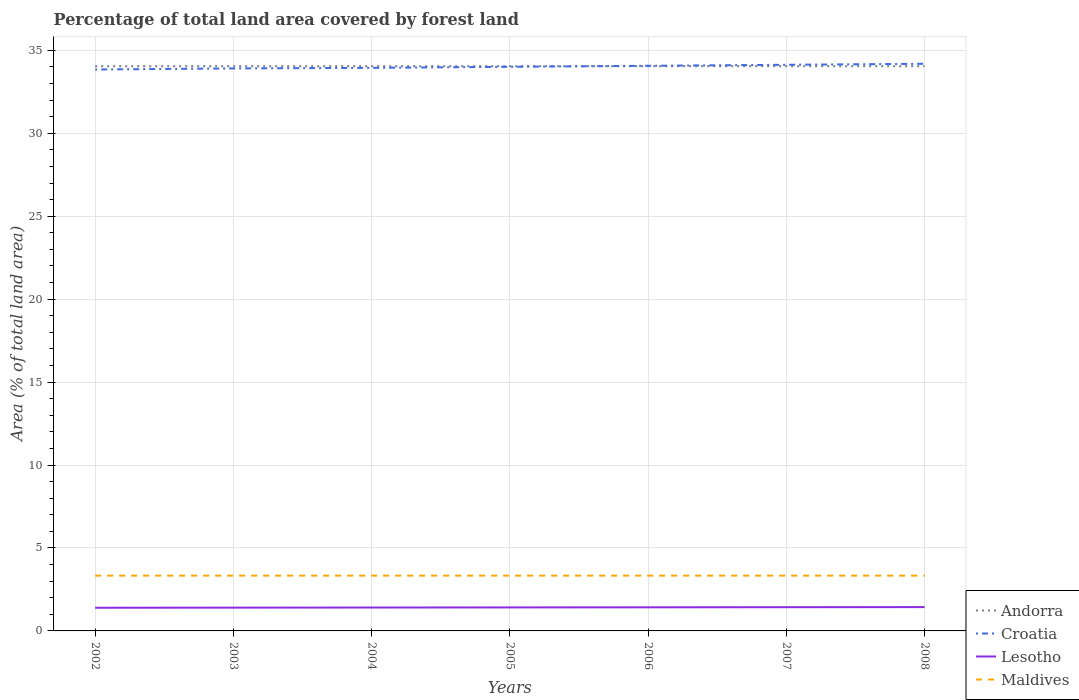How many different coloured lines are there?
Give a very brief answer. 4. Does the line corresponding to Croatia intersect with the line corresponding to Andorra?
Make the answer very short. Yes. Across all years, what is the maximum percentage of forest land in Croatia?
Keep it short and to the point. 33.84. What is the total percentage of forest land in Croatia in the graph?
Give a very brief answer. -0.16. What is the difference between the highest and the lowest percentage of forest land in Maldives?
Keep it short and to the point. 7. Is the percentage of forest land in Maldives strictly greater than the percentage of forest land in Croatia over the years?
Ensure brevity in your answer.  Yes. Are the values on the major ticks of Y-axis written in scientific E-notation?
Offer a very short reply. No. Where does the legend appear in the graph?
Provide a succinct answer. Bottom right. How many legend labels are there?
Provide a short and direct response. 4. What is the title of the graph?
Your response must be concise. Percentage of total land area covered by forest land. What is the label or title of the X-axis?
Give a very brief answer. Years. What is the label or title of the Y-axis?
Provide a short and direct response. Area (% of total land area). What is the Area (% of total land area) of Andorra in 2002?
Provide a short and direct response. 34.04. What is the Area (% of total land area) of Croatia in 2002?
Keep it short and to the point. 33.84. What is the Area (% of total land area) in Lesotho in 2002?
Your answer should be very brief. 1.4. What is the Area (% of total land area) of Maldives in 2002?
Give a very brief answer. 3.33. What is the Area (% of total land area) of Andorra in 2003?
Your answer should be very brief. 34.04. What is the Area (% of total land area) of Croatia in 2003?
Give a very brief answer. 33.91. What is the Area (% of total land area) of Lesotho in 2003?
Keep it short and to the point. 1.4. What is the Area (% of total land area) in Maldives in 2003?
Offer a terse response. 3.33. What is the Area (% of total land area) in Andorra in 2004?
Offer a very short reply. 34.04. What is the Area (% of total land area) in Croatia in 2004?
Your answer should be very brief. 33.94. What is the Area (% of total land area) of Lesotho in 2004?
Ensure brevity in your answer.  1.41. What is the Area (% of total land area) in Maldives in 2004?
Your answer should be very brief. 3.33. What is the Area (% of total land area) of Andorra in 2005?
Provide a short and direct response. 34.04. What is the Area (% of total land area) of Croatia in 2005?
Offer a terse response. 34.01. What is the Area (% of total land area) of Lesotho in 2005?
Keep it short and to the point. 1.42. What is the Area (% of total land area) in Maldives in 2005?
Give a very brief answer. 3.33. What is the Area (% of total land area) of Andorra in 2006?
Make the answer very short. 34.04. What is the Area (% of total land area) in Croatia in 2006?
Offer a very short reply. 34.07. What is the Area (% of total land area) in Lesotho in 2006?
Your answer should be compact. 1.42. What is the Area (% of total land area) in Maldives in 2006?
Provide a succinct answer. 3.33. What is the Area (% of total land area) in Andorra in 2007?
Make the answer very short. 34.04. What is the Area (% of total land area) of Croatia in 2007?
Keep it short and to the point. 34.13. What is the Area (% of total land area) in Lesotho in 2007?
Offer a very short reply. 1.43. What is the Area (% of total land area) in Maldives in 2007?
Keep it short and to the point. 3.33. What is the Area (% of total land area) in Andorra in 2008?
Keep it short and to the point. 34.04. What is the Area (% of total land area) in Croatia in 2008?
Your answer should be compact. 34.19. What is the Area (% of total land area) in Lesotho in 2008?
Provide a short and direct response. 1.44. What is the Area (% of total land area) of Maldives in 2008?
Your answer should be very brief. 3.33. Across all years, what is the maximum Area (% of total land area) in Andorra?
Your answer should be compact. 34.04. Across all years, what is the maximum Area (% of total land area) of Croatia?
Your answer should be very brief. 34.19. Across all years, what is the maximum Area (% of total land area) in Lesotho?
Provide a short and direct response. 1.44. Across all years, what is the maximum Area (% of total land area) of Maldives?
Provide a short and direct response. 3.33. Across all years, what is the minimum Area (% of total land area) of Andorra?
Give a very brief answer. 34.04. Across all years, what is the minimum Area (% of total land area) in Croatia?
Keep it short and to the point. 33.84. Across all years, what is the minimum Area (% of total land area) of Lesotho?
Give a very brief answer. 1.4. Across all years, what is the minimum Area (% of total land area) of Maldives?
Provide a succinct answer. 3.33. What is the total Area (% of total land area) of Andorra in the graph?
Your answer should be compact. 238.3. What is the total Area (% of total land area) in Croatia in the graph?
Give a very brief answer. 238.08. What is the total Area (% of total land area) in Lesotho in the graph?
Your answer should be compact. 9.91. What is the total Area (% of total land area) in Maldives in the graph?
Your response must be concise. 23.33. What is the difference between the Area (% of total land area) in Andorra in 2002 and that in 2003?
Offer a very short reply. 0. What is the difference between the Area (% of total land area) of Croatia in 2002 and that in 2003?
Provide a short and direct response. -0.06. What is the difference between the Area (% of total land area) of Lesotho in 2002 and that in 2003?
Your answer should be compact. -0.01. What is the difference between the Area (% of total land area) in Maldives in 2002 and that in 2003?
Keep it short and to the point. 0. What is the difference between the Area (% of total land area) of Croatia in 2002 and that in 2004?
Your answer should be very brief. -0.1. What is the difference between the Area (% of total land area) in Lesotho in 2002 and that in 2004?
Make the answer very short. -0.01. What is the difference between the Area (% of total land area) of Andorra in 2002 and that in 2005?
Offer a terse response. 0. What is the difference between the Area (% of total land area) of Croatia in 2002 and that in 2005?
Ensure brevity in your answer.  -0.16. What is the difference between the Area (% of total land area) of Lesotho in 2002 and that in 2005?
Offer a terse response. -0.02. What is the difference between the Area (% of total land area) of Andorra in 2002 and that in 2006?
Your response must be concise. 0. What is the difference between the Area (% of total land area) in Croatia in 2002 and that in 2006?
Provide a short and direct response. -0.22. What is the difference between the Area (% of total land area) of Lesotho in 2002 and that in 2006?
Your answer should be very brief. -0.03. What is the difference between the Area (% of total land area) in Andorra in 2002 and that in 2007?
Offer a terse response. 0. What is the difference between the Area (% of total land area) in Croatia in 2002 and that in 2007?
Give a very brief answer. -0.28. What is the difference between the Area (% of total land area) in Lesotho in 2002 and that in 2007?
Provide a succinct answer. -0.03. What is the difference between the Area (% of total land area) of Croatia in 2002 and that in 2008?
Provide a succinct answer. -0.34. What is the difference between the Area (% of total land area) of Lesotho in 2002 and that in 2008?
Your answer should be very brief. -0.04. What is the difference between the Area (% of total land area) in Andorra in 2003 and that in 2004?
Your answer should be compact. 0. What is the difference between the Area (% of total land area) of Croatia in 2003 and that in 2004?
Offer a terse response. -0.03. What is the difference between the Area (% of total land area) in Lesotho in 2003 and that in 2004?
Provide a short and direct response. -0.01. What is the difference between the Area (% of total land area) of Maldives in 2003 and that in 2004?
Your answer should be compact. 0. What is the difference between the Area (% of total land area) in Andorra in 2003 and that in 2005?
Your answer should be compact. 0. What is the difference between the Area (% of total land area) of Croatia in 2003 and that in 2005?
Provide a short and direct response. -0.1. What is the difference between the Area (% of total land area) of Lesotho in 2003 and that in 2005?
Give a very brief answer. -0.01. What is the difference between the Area (% of total land area) in Maldives in 2003 and that in 2005?
Offer a terse response. 0. What is the difference between the Area (% of total land area) of Croatia in 2003 and that in 2006?
Give a very brief answer. -0.16. What is the difference between the Area (% of total land area) in Lesotho in 2003 and that in 2006?
Make the answer very short. -0.02. What is the difference between the Area (% of total land area) in Croatia in 2003 and that in 2007?
Your answer should be very brief. -0.22. What is the difference between the Area (% of total land area) of Lesotho in 2003 and that in 2007?
Make the answer very short. -0.03. What is the difference between the Area (% of total land area) of Andorra in 2003 and that in 2008?
Offer a terse response. 0. What is the difference between the Area (% of total land area) in Croatia in 2003 and that in 2008?
Make the answer very short. -0.28. What is the difference between the Area (% of total land area) of Lesotho in 2003 and that in 2008?
Give a very brief answer. -0.03. What is the difference between the Area (% of total land area) of Maldives in 2003 and that in 2008?
Make the answer very short. 0. What is the difference between the Area (% of total land area) of Croatia in 2004 and that in 2005?
Your response must be concise. -0.06. What is the difference between the Area (% of total land area) in Lesotho in 2004 and that in 2005?
Ensure brevity in your answer.  -0.01. What is the difference between the Area (% of total land area) of Maldives in 2004 and that in 2005?
Offer a terse response. 0. What is the difference between the Area (% of total land area) of Croatia in 2004 and that in 2006?
Ensure brevity in your answer.  -0.13. What is the difference between the Area (% of total land area) in Lesotho in 2004 and that in 2006?
Give a very brief answer. -0.01. What is the difference between the Area (% of total land area) of Maldives in 2004 and that in 2006?
Your answer should be compact. 0. What is the difference between the Area (% of total land area) of Croatia in 2004 and that in 2007?
Make the answer very short. -0.19. What is the difference between the Area (% of total land area) in Lesotho in 2004 and that in 2007?
Your response must be concise. -0.02. What is the difference between the Area (% of total land area) of Andorra in 2004 and that in 2008?
Your response must be concise. 0. What is the difference between the Area (% of total land area) of Croatia in 2004 and that in 2008?
Keep it short and to the point. -0.25. What is the difference between the Area (% of total land area) of Lesotho in 2004 and that in 2008?
Your response must be concise. -0.03. What is the difference between the Area (% of total land area) in Croatia in 2005 and that in 2006?
Keep it short and to the point. -0.06. What is the difference between the Area (% of total land area) of Lesotho in 2005 and that in 2006?
Keep it short and to the point. -0.01. What is the difference between the Area (% of total land area) in Croatia in 2005 and that in 2007?
Offer a very short reply. -0.12. What is the difference between the Area (% of total land area) of Lesotho in 2005 and that in 2007?
Your answer should be compact. -0.01. What is the difference between the Area (% of total land area) in Croatia in 2005 and that in 2008?
Your answer should be very brief. -0.18. What is the difference between the Area (% of total land area) of Lesotho in 2005 and that in 2008?
Provide a short and direct response. -0.02. What is the difference between the Area (% of total land area) of Maldives in 2005 and that in 2008?
Provide a short and direct response. 0. What is the difference between the Area (% of total land area) in Andorra in 2006 and that in 2007?
Ensure brevity in your answer.  0. What is the difference between the Area (% of total land area) of Croatia in 2006 and that in 2007?
Keep it short and to the point. -0.06. What is the difference between the Area (% of total land area) of Lesotho in 2006 and that in 2007?
Give a very brief answer. -0.01. What is the difference between the Area (% of total land area) in Croatia in 2006 and that in 2008?
Give a very brief answer. -0.12. What is the difference between the Area (% of total land area) in Lesotho in 2006 and that in 2008?
Your response must be concise. -0.01. What is the difference between the Area (% of total land area) in Maldives in 2006 and that in 2008?
Ensure brevity in your answer.  0. What is the difference between the Area (% of total land area) in Andorra in 2007 and that in 2008?
Your response must be concise. 0. What is the difference between the Area (% of total land area) in Croatia in 2007 and that in 2008?
Give a very brief answer. -0.06. What is the difference between the Area (% of total land area) of Lesotho in 2007 and that in 2008?
Offer a terse response. -0.01. What is the difference between the Area (% of total land area) in Andorra in 2002 and the Area (% of total land area) in Croatia in 2003?
Offer a terse response. 0.13. What is the difference between the Area (% of total land area) of Andorra in 2002 and the Area (% of total land area) of Lesotho in 2003?
Offer a very short reply. 32.64. What is the difference between the Area (% of total land area) in Andorra in 2002 and the Area (% of total land area) in Maldives in 2003?
Provide a succinct answer. 30.71. What is the difference between the Area (% of total land area) of Croatia in 2002 and the Area (% of total land area) of Lesotho in 2003?
Offer a very short reply. 32.44. What is the difference between the Area (% of total land area) of Croatia in 2002 and the Area (% of total land area) of Maldives in 2003?
Ensure brevity in your answer.  30.51. What is the difference between the Area (% of total land area) of Lesotho in 2002 and the Area (% of total land area) of Maldives in 2003?
Offer a terse response. -1.94. What is the difference between the Area (% of total land area) in Andorra in 2002 and the Area (% of total land area) in Croatia in 2004?
Keep it short and to the point. 0.1. What is the difference between the Area (% of total land area) of Andorra in 2002 and the Area (% of total land area) of Lesotho in 2004?
Offer a very short reply. 32.63. What is the difference between the Area (% of total land area) in Andorra in 2002 and the Area (% of total land area) in Maldives in 2004?
Your answer should be compact. 30.71. What is the difference between the Area (% of total land area) of Croatia in 2002 and the Area (% of total land area) of Lesotho in 2004?
Make the answer very short. 32.43. What is the difference between the Area (% of total land area) in Croatia in 2002 and the Area (% of total land area) in Maldives in 2004?
Keep it short and to the point. 30.51. What is the difference between the Area (% of total land area) in Lesotho in 2002 and the Area (% of total land area) in Maldives in 2004?
Make the answer very short. -1.94. What is the difference between the Area (% of total land area) of Andorra in 2002 and the Area (% of total land area) of Croatia in 2005?
Your response must be concise. 0.04. What is the difference between the Area (% of total land area) in Andorra in 2002 and the Area (% of total land area) in Lesotho in 2005?
Offer a very short reply. 32.63. What is the difference between the Area (% of total land area) of Andorra in 2002 and the Area (% of total land area) of Maldives in 2005?
Provide a short and direct response. 30.71. What is the difference between the Area (% of total land area) of Croatia in 2002 and the Area (% of total land area) of Lesotho in 2005?
Your answer should be compact. 32.43. What is the difference between the Area (% of total land area) in Croatia in 2002 and the Area (% of total land area) in Maldives in 2005?
Your answer should be compact. 30.51. What is the difference between the Area (% of total land area) in Lesotho in 2002 and the Area (% of total land area) in Maldives in 2005?
Your answer should be very brief. -1.94. What is the difference between the Area (% of total land area) in Andorra in 2002 and the Area (% of total land area) in Croatia in 2006?
Provide a succinct answer. -0.02. What is the difference between the Area (% of total land area) of Andorra in 2002 and the Area (% of total land area) of Lesotho in 2006?
Ensure brevity in your answer.  32.62. What is the difference between the Area (% of total land area) of Andorra in 2002 and the Area (% of total land area) of Maldives in 2006?
Your answer should be compact. 30.71. What is the difference between the Area (% of total land area) in Croatia in 2002 and the Area (% of total land area) in Lesotho in 2006?
Provide a succinct answer. 32.42. What is the difference between the Area (% of total land area) in Croatia in 2002 and the Area (% of total land area) in Maldives in 2006?
Your answer should be compact. 30.51. What is the difference between the Area (% of total land area) of Lesotho in 2002 and the Area (% of total land area) of Maldives in 2006?
Make the answer very short. -1.94. What is the difference between the Area (% of total land area) in Andorra in 2002 and the Area (% of total land area) in Croatia in 2007?
Offer a terse response. -0.09. What is the difference between the Area (% of total land area) of Andorra in 2002 and the Area (% of total land area) of Lesotho in 2007?
Offer a terse response. 32.61. What is the difference between the Area (% of total land area) in Andorra in 2002 and the Area (% of total land area) in Maldives in 2007?
Your answer should be very brief. 30.71. What is the difference between the Area (% of total land area) in Croatia in 2002 and the Area (% of total land area) in Lesotho in 2007?
Provide a succinct answer. 32.41. What is the difference between the Area (% of total land area) of Croatia in 2002 and the Area (% of total land area) of Maldives in 2007?
Your answer should be compact. 30.51. What is the difference between the Area (% of total land area) in Lesotho in 2002 and the Area (% of total land area) in Maldives in 2007?
Provide a short and direct response. -1.94. What is the difference between the Area (% of total land area) in Andorra in 2002 and the Area (% of total land area) in Croatia in 2008?
Ensure brevity in your answer.  -0.15. What is the difference between the Area (% of total land area) in Andorra in 2002 and the Area (% of total land area) in Lesotho in 2008?
Provide a succinct answer. 32.61. What is the difference between the Area (% of total land area) of Andorra in 2002 and the Area (% of total land area) of Maldives in 2008?
Provide a succinct answer. 30.71. What is the difference between the Area (% of total land area) of Croatia in 2002 and the Area (% of total land area) of Lesotho in 2008?
Make the answer very short. 32.41. What is the difference between the Area (% of total land area) of Croatia in 2002 and the Area (% of total land area) of Maldives in 2008?
Your answer should be compact. 30.51. What is the difference between the Area (% of total land area) of Lesotho in 2002 and the Area (% of total land area) of Maldives in 2008?
Your response must be concise. -1.94. What is the difference between the Area (% of total land area) of Andorra in 2003 and the Area (% of total land area) of Croatia in 2004?
Your answer should be compact. 0.1. What is the difference between the Area (% of total land area) of Andorra in 2003 and the Area (% of total land area) of Lesotho in 2004?
Provide a succinct answer. 32.63. What is the difference between the Area (% of total land area) of Andorra in 2003 and the Area (% of total land area) of Maldives in 2004?
Keep it short and to the point. 30.71. What is the difference between the Area (% of total land area) in Croatia in 2003 and the Area (% of total land area) in Lesotho in 2004?
Ensure brevity in your answer.  32.5. What is the difference between the Area (% of total land area) in Croatia in 2003 and the Area (% of total land area) in Maldives in 2004?
Your answer should be compact. 30.57. What is the difference between the Area (% of total land area) of Lesotho in 2003 and the Area (% of total land area) of Maldives in 2004?
Offer a very short reply. -1.93. What is the difference between the Area (% of total land area) of Andorra in 2003 and the Area (% of total land area) of Croatia in 2005?
Offer a terse response. 0.04. What is the difference between the Area (% of total land area) of Andorra in 2003 and the Area (% of total land area) of Lesotho in 2005?
Provide a succinct answer. 32.63. What is the difference between the Area (% of total land area) of Andorra in 2003 and the Area (% of total land area) of Maldives in 2005?
Ensure brevity in your answer.  30.71. What is the difference between the Area (% of total land area) in Croatia in 2003 and the Area (% of total land area) in Lesotho in 2005?
Your answer should be very brief. 32.49. What is the difference between the Area (% of total land area) of Croatia in 2003 and the Area (% of total land area) of Maldives in 2005?
Keep it short and to the point. 30.57. What is the difference between the Area (% of total land area) in Lesotho in 2003 and the Area (% of total land area) in Maldives in 2005?
Provide a succinct answer. -1.93. What is the difference between the Area (% of total land area) in Andorra in 2003 and the Area (% of total land area) in Croatia in 2006?
Your answer should be compact. -0.02. What is the difference between the Area (% of total land area) in Andorra in 2003 and the Area (% of total land area) in Lesotho in 2006?
Make the answer very short. 32.62. What is the difference between the Area (% of total land area) of Andorra in 2003 and the Area (% of total land area) of Maldives in 2006?
Provide a short and direct response. 30.71. What is the difference between the Area (% of total land area) of Croatia in 2003 and the Area (% of total land area) of Lesotho in 2006?
Keep it short and to the point. 32.49. What is the difference between the Area (% of total land area) of Croatia in 2003 and the Area (% of total land area) of Maldives in 2006?
Make the answer very short. 30.57. What is the difference between the Area (% of total land area) in Lesotho in 2003 and the Area (% of total land area) in Maldives in 2006?
Offer a very short reply. -1.93. What is the difference between the Area (% of total land area) in Andorra in 2003 and the Area (% of total land area) in Croatia in 2007?
Make the answer very short. -0.09. What is the difference between the Area (% of total land area) of Andorra in 2003 and the Area (% of total land area) of Lesotho in 2007?
Keep it short and to the point. 32.61. What is the difference between the Area (% of total land area) of Andorra in 2003 and the Area (% of total land area) of Maldives in 2007?
Ensure brevity in your answer.  30.71. What is the difference between the Area (% of total land area) of Croatia in 2003 and the Area (% of total land area) of Lesotho in 2007?
Your answer should be compact. 32.48. What is the difference between the Area (% of total land area) of Croatia in 2003 and the Area (% of total land area) of Maldives in 2007?
Offer a very short reply. 30.57. What is the difference between the Area (% of total land area) in Lesotho in 2003 and the Area (% of total land area) in Maldives in 2007?
Provide a short and direct response. -1.93. What is the difference between the Area (% of total land area) of Andorra in 2003 and the Area (% of total land area) of Croatia in 2008?
Provide a short and direct response. -0.15. What is the difference between the Area (% of total land area) of Andorra in 2003 and the Area (% of total land area) of Lesotho in 2008?
Make the answer very short. 32.61. What is the difference between the Area (% of total land area) of Andorra in 2003 and the Area (% of total land area) of Maldives in 2008?
Your answer should be compact. 30.71. What is the difference between the Area (% of total land area) in Croatia in 2003 and the Area (% of total land area) in Lesotho in 2008?
Offer a very short reply. 32.47. What is the difference between the Area (% of total land area) in Croatia in 2003 and the Area (% of total land area) in Maldives in 2008?
Provide a succinct answer. 30.57. What is the difference between the Area (% of total land area) in Lesotho in 2003 and the Area (% of total land area) in Maldives in 2008?
Your response must be concise. -1.93. What is the difference between the Area (% of total land area) of Andorra in 2004 and the Area (% of total land area) of Croatia in 2005?
Offer a terse response. 0.04. What is the difference between the Area (% of total land area) in Andorra in 2004 and the Area (% of total land area) in Lesotho in 2005?
Make the answer very short. 32.63. What is the difference between the Area (% of total land area) in Andorra in 2004 and the Area (% of total land area) in Maldives in 2005?
Provide a short and direct response. 30.71. What is the difference between the Area (% of total land area) in Croatia in 2004 and the Area (% of total land area) in Lesotho in 2005?
Your response must be concise. 32.53. What is the difference between the Area (% of total land area) of Croatia in 2004 and the Area (% of total land area) of Maldives in 2005?
Keep it short and to the point. 30.61. What is the difference between the Area (% of total land area) in Lesotho in 2004 and the Area (% of total land area) in Maldives in 2005?
Make the answer very short. -1.92. What is the difference between the Area (% of total land area) of Andorra in 2004 and the Area (% of total land area) of Croatia in 2006?
Your response must be concise. -0.02. What is the difference between the Area (% of total land area) in Andorra in 2004 and the Area (% of total land area) in Lesotho in 2006?
Provide a short and direct response. 32.62. What is the difference between the Area (% of total land area) of Andorra in 2004 and the Area (% of total land area) of Maldives in 2006?
Keep it short and to the point. 30.71. What is the difference between the Area (% of total land area) of Croatia in 2004 and the Area (% of total land area) of Lesotho in 2006?
Keep it short and to the point. 32.52. What is the difference between the Area (% of total land area) of Croatia in 2004 and the Area (% of total land area) of Maldives in 2006?
Your response must be concise. 30.61. What is the difference between the Area (% of total land area) in Lesotho in 2004 and the Area (% of total land area) in Maldives in 2006?
Give a very brief answer. -1.92. What is the difference between the Area (% of total land area) in Andorra in 2004 and the Area (% of total land area) in Croatia in 2007?
Offer a terse response. -0.09. What is the difference between the Area (% of total land area) in Andorra in 2004 and the Area (% of total land area) in Lesotho in 2007?
Offer a terse response. 32.61. What is the difference between the Area (% of total land area) of Andorra in 2004 and the Area (% of total land area) of Maldives in 2007?
Offer a terse response. 30.71. What is the difference between the Area (% of total land area) of Croatia in 2004 and the Area (% of total land area) of Lesotho in 2007?
Make the answer very short. 32.51. What is the difference between the Area (% of total land area) in Croatia in 2004 and the Area (% of total land area) in Maldives in 2007?
Your answer should be very brief. 30.61. What is the difference between the Area (% of total land area) of Lesotho in 2004 and the Area (% of total land area) of Maldives in 2007?
Provide a succinct answer. -1.92. What is the difference between the Area (% of total land area) in Andorra in 2004 and the Area (% of total land area) in Croatia in 2008?
Keep it short and to the point. -0.15. What is the difference between the Area (% of total land area) in Andorra in 2004 and the Area (% of total land area) in Lesotho in 2008?
Give a very brief answer. 32.61. What is the difference between the Area (% of total land area) of Andorra in 2004 and the Area (% of total land area) of Maldives in 2008?
Offer a very short reply. 30.71. What is the difference between the Area (% of total land area) in Croatia in 2004 and the Area (% of total land area) in Lesotho in 2008?
Offer a terse response. 32.51. What is the difference between the Area (% of total land area) in Croatia in 2004 and the Area (% of total land area) in Maldives in 2008?
Offer a terse response. 30.61. What is the difference between the Area (% of total land area) in Lesotho in 2004 and the Area (% of total land area) in Maldives in 2008?
Give a very brief answer. -1.92. What is the difference between the Area (% of total land area) of Andorra in 2005 and the Area (% of total land area) of Croatia in 2006?
Offer a terse response. -0.02. What is the difference between the Area (% of total land area) in Andorra in 2005 and the Area (% of total land area) in Lesotho in 2006?
Your answer should be very brief. 32.62. What is the difference between the Area (% of total land area) of Andorra in 2005 and the Area (% of total land area) of Maldives in 2006?
Provide a succinct answer. 30.71. What is the difference between the Area (% of total land area) in Croatia in 2005 and the Area (% of total land area) in Lesotho in 2006?
Give a very brief answer. 32.58. What is the difference between the Area (% of total land area) of Croatia in 2005 and the Area (% of total land area) of Maldives in 2006?
Give a very brief answer. 30.67. What is the difference between the Area (% of total land area) of Lesotho in 2005 and the Area (% of total land area) of Maldives in 2006?
Your response must be concise. -1.92. What is the difference between the Area (% of total land area) of Andorra in 2005 and the Area (% of total land area) of Croatia in 2007?
Offer a terse response. -0.09. What is the difference between the Area (% of total land area) of Andorra in 2005 and the Area (% of total land area) of Lesotho in 2007?
Ensure brevity in your answer.  32.61. What is the difference between the Area (% of total land area) of Andorra in 2005 and the Area (% of total land area) of Maldives in 2007?
Give a very brief answer. 30.71. What is the difference between the Area (% of total land area) in Croatia in 2005 and the Area (% of total land area) in Lesotho in 2007?
Give a very brief answer. 32.58. What is the difference between the Area (% of total land area) of Croatia in 2005 and the Area (% of total land area) of Maldives in 2007?
Ensure brevity in your answer.  30.67. What is the difference between the Area (% of total land area) in Lesotho in 2005 and the Area (% of total land area) in Maldives in 2007?
Offer a terse response. -1.92. What is the difference between the Area (% of total land area) of Andorra in 2005 and the Area (% of total land area) of Croatia in 2008?
Ensure brevity in your answer.  -0.15. What is the difference between the Area (% of total land area) of Andorra in 2005 and the Area (% of total land area) of Lesotho in 2008?
Your answer should be compact. 32.61. What is the difference between the Area (% of total land area) in Andorra in 2005 and the Area (% of total land area) in Maldives in 2008?
Ensure brevity in your answer.  30.71. What is the difference between the Area (% of total land area) of Croatia in 2005 and the Area (% of total land area) of Lesotho in 2008?
Give a very brief answer. 32.57. What is the difference between the Area (% of total land area) of Croatia in 2005 and the Area (% of total land area) of Maldives in 2008?
Keep it short and to the point. 30.67. What is the difference between the Area (% of total land area) of Lesotho in 2005 and the Area (% of total land area) of Maldives in 2008?
Offer a very short reply. -1.92. What is the difference between the Area (% of total land area) of Andorra in 2006 and the Area (% of total land area) of Croatia in 2007?
Give a very brief answer. -0.09. What is the difference between the Area (% of total land area) in Andorra in 2006 and the Area (% of total land area) in Lesotho in 2007?
Offer a very short reply. 32.61. What is the difference between the Area (% of total land area) of Andorra in 2006 and the Area (% of total land area) of Maldives in 2007?
Provide a short and direct response. 30.71. What is the difference between the Area (% of total land area) of Croatia in 2006 and the Area (% of total land area) of Lesotho in 2007?
Your answer should be compact. 32.64. What is the difference between the Area (% of total land area) in Croatia in 2006 and the Area (% of total land area) in Maldives in 2007?
Your answer should be very brief. 30.73. What is the difference between the Area (% of total land area) in Lesotho in 2006 and the Area (% of total land area) in Maldives in 2007?
Keep it short and to the point. -1.91. What is the difference between the Area (% of total land area) of Andorra in 2006 and the Area (% of total land area) of Croatia in 2008?
Your answer should be compact. -0.15. What is the difference between the Area (% of total land area) of Andorra in 2006 and the Area (% of total land area) of Lesotho in 2008?
Ensure brevity in your answer.  32.61. What is the difference between the Area (% of total land area) in Andorra in 2006 and the Area (% of total land area) in Maldives in 2008?
Offer a very short reply. 30.71. What is the difference between the Area (% of total land area) of Croatia in 2006 and the Area (% of total land area) of Lesotho in 2008?
Offer a terse response. 32.63. What is the difference between the Area (% of total land area) of Croatia in 2006 and the Area (% of total land area) of Maldives in 2008?
Offer a terse response. 30.73. What is the difference between the Area (% of total land area) of Lesotho in 2006 and the Area (% of total land area) of Maldives in 2008?
Provide a succinct answer. -1.91. What is the difference between the Area (% of total land area) of Andorra in 2007 and the Area (% of total land area) of Croatia in 2008?
Your response must be concise. -0.15. What is the difference between the Area (% of total land area) in Andorra in 2007 and the Area (% of total land area) in Lesotho in 2008?
Offer a terse response. 32.61. What is the difference between the Area (% of total land area) of Andorra in 2007 and the Area (% of total land area) of Maldives in 2008?
Offer a terse response. 30.71. What is the difference between the Area (% of total land area) in Croatia in 2007 and the Area (% of total land area) in Lesotho in 2008?
Your response must be concise. 32.69. What is the difference between the Area (% of total land area) in Croatia in 2007 and the Area (% of total land area) in Maldives in 2008?
Offer a very short reply. 30.79. What is the difference between the Area (% of total land area) in Lesotho in 2007 and the Area (% of total land area) in Maldives in 2008?
Ensure brevity in your answer.  -1.9. What is the average Area (% of total land area) of Andorra per year?
Offer a terse response. 34.04. What is the average Area (% of total land area) in Croatia per year?
Offer a very short reply. 34.01. What is the average Area (% of total land area) of Lesotho per year?
Offer a terse response. 1.42. What is the average Area (% of total land area) of Maldives per year?
Your response must be concise. 3.33. In the year 2002, what is the difference between the Area (% of total land area) in Andorra and Area (% of total land area) in Croatia?
Give a very brief answer. 0.2. In the year 2002, what is the difference between the Area (% of total land area) of Andorra and Area (% of total land area) of Lesotho?
Your answer should be compact. 32.65. In the year 2002, what is the difference between the Area (% of total land area) of Andorra and Area (% of total land area) of Maldives?
Provide a short and direct response. 30.71. In the year 2002, what is the difference between the Area (% of total land area) of Croatia and Area (% of total land area) of Lesotho?
Make the answer very short. 32.45. In the year 2002, what is the difference between the Area (% of total land area) in Croatia and Area (% of total land area) in Maldives?
Ensure brevity in your answer.  30.51. In the year 2002, what is the difference between the Area (% of total land area) in Lesotho and Area (% of total land area) in Maldives?
Your response must be concise. -1.94. In the year 2003, what is the difference between the Area (% of total land area) in Andorra and Area (% of total land area) in Croatia?
Offer a terse response. 0.13. In the year 2003, what is the difference between the Area (% of total land area) of Andorra and Area (% of total land area) of Lesotho?
Ensure brevity in your answer.  32.64. In the year 2003, what is the difference between the Area (% of total land area) of Andorra and Area (% of total land area) of Maldives?
Offer a very short reply. 30.71. In the year 2003, what is the difference between the Area (% of total land area) in Croatia and Area (% of total land area) in Lesotho?
Provide a succinct answer. 32.5. In the year 2003, what is the difference between the Area (% of total land area) in Croatia and Area (% of total land area) in Maldives?
Give a very brief answer. 30.57. In the year 2003, what is the difference between the Area (% of total land area) of Lesotho and Area (% of total land area) of Maldives?
Your answer should be compact. -1.93. In the year 2004, what is the difference between the Area (% of total land area) in Andorra and Area (% of total land area) in Croatia?
Provide a succinct answer. 0.1. In the year 2004, what is the difference between the Area (% of total land area) of Andorra and Area (% of total land area) of Lesotho?
Make the answer very short. 32.63. In the year 2004, what is the difference between the Area (% of total land area) of Andorra and Area (% of total land area) of Maldives?
Ensure brevity in your answer.  30.71. In the year 2004, what is the difference between the Area (% of total land area) in Croatia and Area (% of total land area) in Lesotho?
Your response must be concise. 32.53. In the year 2004, what is the difference between the Area (% of total land area) of Croatia and Area (% of total land area) of Maldives?
Keep it short and to the point. 30.61. In the year 2004, what is the difference between the Area (% of total land area) in Lesotho and Area (% of total land area) in Maldives?
Your answer should be compact. -1.92. In the year 2005, what is the difference between the Area (% of total land area) of Andorra and Area (% of total land area) of Croatia?
Keep it short and to the point. 0.04. In the year 2005, what is the difference between the Area (% of total land area) of Andorra and Area (% of total land area) of Lesotho?
Offer a terse response. 32.63. In the year 2005, what is the difference between the Area (% of total land area) in Andorra and Area (% of total land area) in Maldives?
Offer a terse response. 30.71. In the year 2005, what is the difference between the Area (% of total land area) of Croatia and Area (% of total land area) of Lesotho?
Offer a very short reply. 32.59. In the year 2005, what is the difference between the Area (% of total land area) of Croatia and Area (% of total land area) of Maldives?
Ensure brevity in your answer.  30.67. In the year 2005, what is the difference between the Area (% of total land area) of Lesotho and Area (% of total land area) of Maldives?
Provide a short and direct response. -1.92. In the year 2006, what is the difference between the Area (% of total land area) of Andorra and Area (% of total land area) of Croatia?
Give a very brief answer. -0.02. In the year 2006, what is the difference between the Area (% of total land area) in Andorra and Area (% of total land area) in Lesotho?
Your answer should be very brief. 32.62. In the year 2006, what is the difference between the Area (% of total land area) in Andorra and Area (% of total land area) in Maldives?
Provide a succinct answer. 30.71. In the year 2006, what is the difference between the Area (% of total land area) of Croatia and Area (% of total land area) of Lesotho?
Your answer should be compact. 32.64. In the year 2006, what is the difference between the Area (% of total land area) in Croatia and Area (% of total land area) in Maldives?
Your answer should be compact. 30.73. In the year 2006, what is the difference between the Area (% of total land area) of Lesotho and Area (% of total land area) of Maldives?
Your answer should be very brief. -1.91. In the year 2007, what is the difference between the Area (% of total land area) of Andorra and Area (% of total land area) of Croatia?
Your answer should be compact. -0.09. In the year 2007, what is the difference between the Area (% of total land area) in Andorra and Area (% of total land area) in Lesotho?
Provide a succinct answer. 32.61. In the year 2007, what is the difference between the Area (% of total land area) of Andorra and Area (% of total land area) of Maldives?
Make the answer very short. 30.71. In the year 2007, what is the difference between the Area (% of total land area) in Croatia and Area (% of total land area) in Lesotho?
Offer a terse response. 32.7. In the year 2007, what is the difference between the Area (% of total land area) of Croatia and Area (% of total land area) of Maldives?
Ensure brevity in your answer.  30.79. In the year 2007, what is the difference between the Area (% of total land area) in Lesotho and Area (% of total land area) in Maldives?
Keep it short and to the point. -1.9. In the year 2008, what is the difference between the Area (% of total land area) of Andorra and Area (% of total land area) of Croatia?
Make the answer very short. -0.15. In the year 2008, what is the difference between the Area (% of total land area) of Andorra and Area (% of total land area) of Lesotho?
Make the answer very short. 32.61. In the year 2008, what is the difference between the Area (% of total land area) in Andorra and Area (% of total land area) in Maldives?
Offer a terse response. 30.71. In the year 2008, what is the difference between the Area (% of total land area) in Croatia and Area (% of total land area) in Lesotho?
Provide a succinct answer. 32.75. In the year 2008, what is the difference between the Area (% of total land area) of Croatia and Area (% of total land area) of Maldives?
Your response must be concise. 30.86. In the year 2008, what is the difference between the Area (% of total land area) of Lesotho and Area (% of total land area) of Maldives?
Your answer should be compact. -1.9. What is the ratio of the Area (% of total land area) of Andorra in 2002 to that in 2003?
Ensure brevity in your answer.  1. What is the ratio of the Area (% of total land area) of Croatia in 2002 to that in 2003?
Keep it short and to the point. 1. What is the ratio of the Area (% of total land area) of Croatia in 2002 to that in 2004?
Your answer should be compact. 1. What is the ratio of the Area (% of total land area) in Lesotho in 2002 to that in 2004?
Make the answer very short. 0.99. What is the ratio of the Area (% of total land area) in Maldives in 2002 to that in 2004?
Provide a short and direct response. 1. What is the ratio of the Area (% of total land area) in Andorra in 2002 to that in 2005?
Provide a short and direct response. 1. What is the ratio of the Area (% of total land area) of Croatia in 2002 to that in 2006?
Your response must be concise. 0.99. What is the ratio of the Area (% of total land area) in Lesotho in 2002 to that in 2006?
Your answer should be compact. 0.98. What is the ratio of the Area (% of total land area) of Maldives in 2002 to that in 2006?
Your response must be concise. 1. What is the ratio of the Area (% of total land area) of Croatia in 2002 to that in 2007?
Offer a terse response. 0.99. What is the ratio of the Area (% of total land area) in Lesotho in 2002 to that in 2007?
Give a very brief answer. 0.98. What is the ratio of the Area (% of total land area) of Andorra in 2002 to that in 2008?
Your answer should be very brief. 1. What is the ratio of the Area (% of total land area) of Lesotho in 2002 to that in 2008?
Offer a terse response. 0.97. What is the ratio of the Area (% of total land area) of Maldives in 2002 to that in 2008?
Give a very brief answer. 1. What is the ratio of the Area (% of total land area) in Andorra in 2003 to that in 2005?
Your response must be concise. 1. What is the ratio of the Area (% of total land area) of Lesotho in 2003 to that in 2005?
Your answer should be very brief. 0.99. What is the ratio of the Area (% of total land area) of Maldives in 2003 to that in 2005?
Offer a terse response. 1. What is the ratio of the Area (% of total land area) of Lesotho in 2003 to that in 2006?
Offer a terse response. 0.99. What is the ratio of the Area (% of total land area) in Andorra in 2003 to that in 2007?
Provide a short and direct response. 1. What is the ratio of the Area (% of total land area) in Croatia in 2003 to that in 2007?
Provide a short and direct response. 0.99. What is the ratio of the Area (% of total land area) of Lesotho in 2003 to that in 2007?
Keep it short and to the point. 0.98. What is the ratio of the Area (% of total land area) in Andorra in 2003 to that in 2008?
Give a very brief answer. 1. What is the ratio of the Area (% of total land area) in Lesotho in 2003 to that in 2008?
Keep it short and to the point. 0.98. What is the ratio of the Area (% of total land area) of Maldives in 2003 to that in 2008?
Make the answer very short. 1. What is the ratio of the Area (% of total land area) of Lesotho in 2004 to that in 2005?
Your response must be concise. 1. What is the ratio of the Area (% of total land area) in Andorra in 2004 to that in 2006?
Give a very brief answer. 1. What is the ratio of the Area (% of total land area) of Croatia in 2004 to that in 2006?
Give a very brief answer. 1. What is the ratio of the Area (% of total land area) of Lesotho in 2004 to that in 2006?
Provide a succinct answer. 0.99. What is the ratio of the Area (% of total land area) in Maldives in 2004 to that in 2006?
Your answer should be very brief. 1. What is the ratio of the Area (% of total land area) of Lesotho in 2004 to that in 2007?
Offer a very short reply. 0.99. What is the ratio of the Area (% of total land area) in Lesotho in 2004 to that in 2008?
Ensure brevity in your answer.  0.98. What is the ratio of the Area (% of total land area) in Maldives in 2004 to that in 2008?
Provide a succinct answer. 1. What is the ratio of the Area (% of total land area) of Andorra in 2005 to that in 2006?
Offer a very short reply. 1. What is the ratio of the Area (% of total land area) of Lesotho in 2005 to that in 2006?
Your response must be concise. 1. What is the ratio of the Area (% of total land area) in Andorra in 2005 to that in 2008?
Your answer should be very brief. 1. What is the ratio of the Area (% of total land area) of Lesotho in 2005 to that in 2008?
Keep it short and to the point. 0.99. What is the ratio of the Area (% of total land area) in Maldives in 2005 to that in 2008?
Keep it short and to the point. 1. What is the ratio of the Area (% of total land area) in Lesotho in 2006 to that in 2007?
Your answer should be compact. 1. What is the ratio of the Area (% of total land area) of Maldives in 2006 to that in 2007?
Your response must be concise. 1. What is the ratio of the Area (% of total land area) in Croatia in 2006 to that in 2008?
Give a very brief answer. 1. What is the ratio of the Area (% of total land area) in Croatia in 2007 to that in 2008?
Ensure brevity in your answer.  1. What is the ratio of the Area (% of total land area) in Lesotho in 2007 to that in 2008?
Your answer should be very brief. 1. What is the ratio of the Area (% of total land area) in Maldives in 2007 to that in 2008?
Ensure brevity in your answer.  1. What is the difference between the highest and the second highest Area (% of total land area) in Croatia?
Make the answer very short. 0.06. What is the difference between the highest and the second highest Area (% of total land area) of Lesotho?
Provide a succinct answer. 0.01. What is the difference between the highest and the second highest Area (% of total land area) in Maldives?
Your answer should be compact. 0. What is the difference between the highest and the lowest Area (% of total land area) of Croatia?
Make the answer very short. 0.34. What is the difference between the highest and the lowest Area (% of total land area) in Lesotho?
Ensure brevity in your answer.  0.04. 